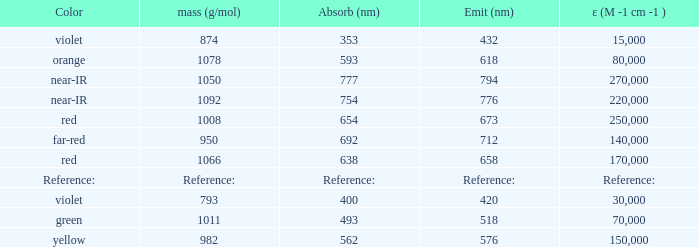Which Emission (in nanometers) has an absorbtion of 593 nm? 618.0. 